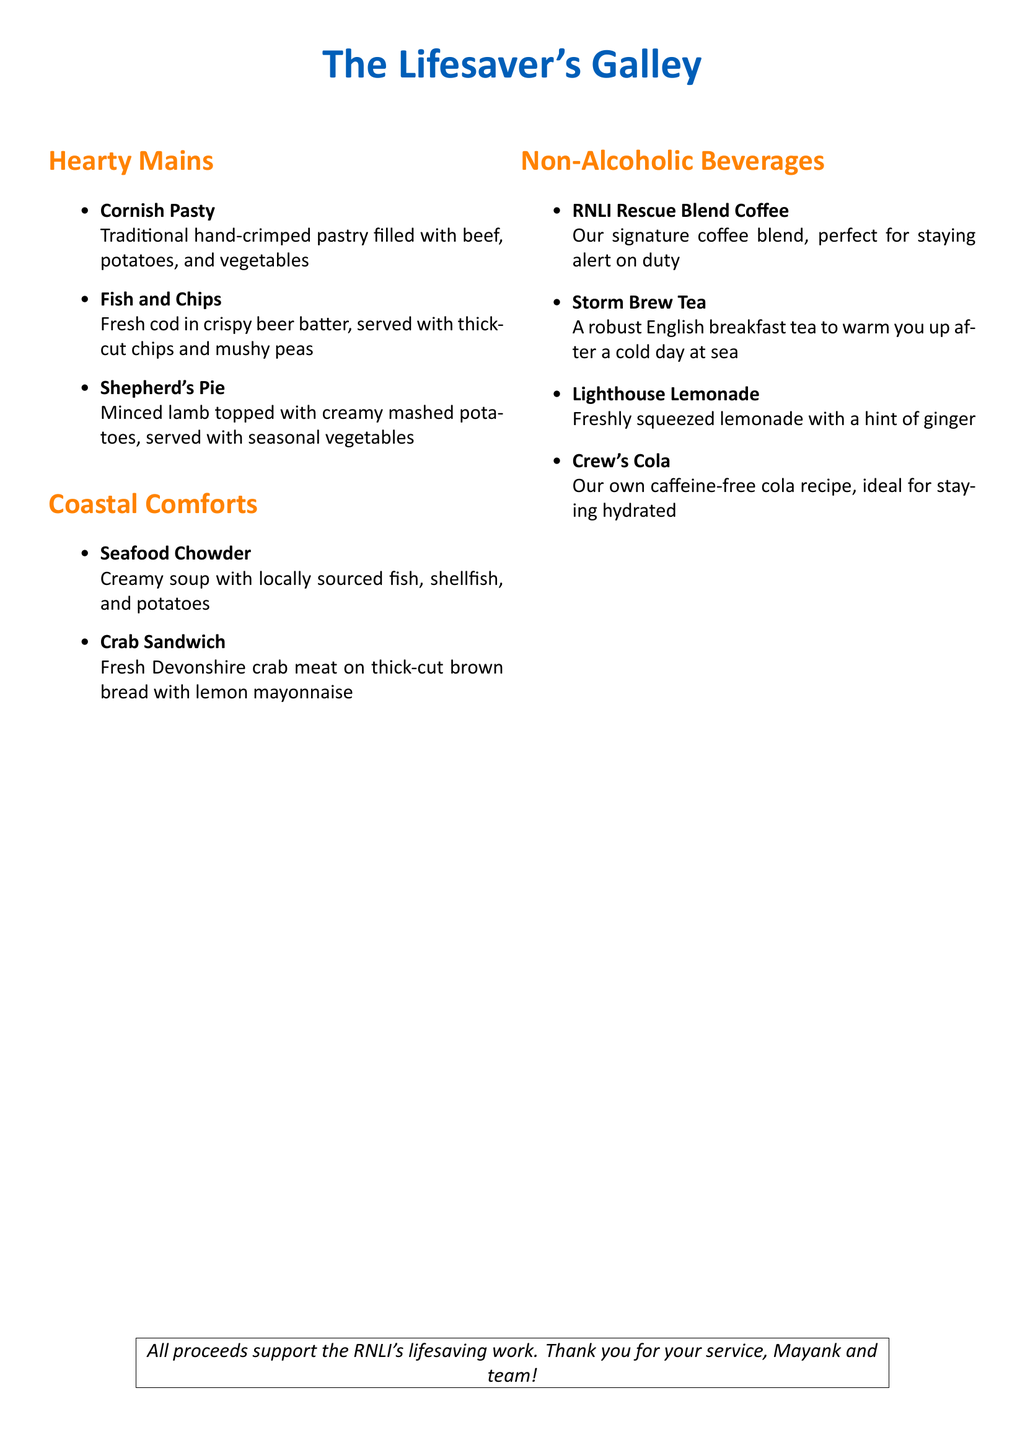What is the name of the menu? The title at the top of the menu specifies the name of the restaurant, which is "The Lifesaver's Galley."
Answer: The Lifesaver's Galley How many hearty mains are listed? The menu lists three different hearty mains under the "Hearty Mains" section.
Answer: 3 What is the first item under Coastal Comforts? The first item in the "Coastal Comforts" section is the "Seafood Chowder."
Answer: Seafood Chowder What is the name of the non-alcoholic beverage that is a coffee blend? The non-alcoholic beverage that is a coffee blend is called "RNLI Rescue Blend Coffee."
Answer: RNLI Rescue Blend Coffee Which fish is used in the Fish and Chips? The Fish and Chips are made with "fresh cod."
Answer: fresh cod How is the crab sandwich served? The crab sandwich is served on "thick-cut brown bread with lemon mayonnaise."
Answer: thick-cut brown bread with lemon mayonnaise What kind of tea is listed on the menu? The menu lists "Storm Brew Tea," which is described as a robust English breakfast tea.
Answer: Storm Brew Tea What does the proceeds from the menu support? The proceeds from the menu support the RNLI's "lifesaving work."
Answer: lifesaving work 